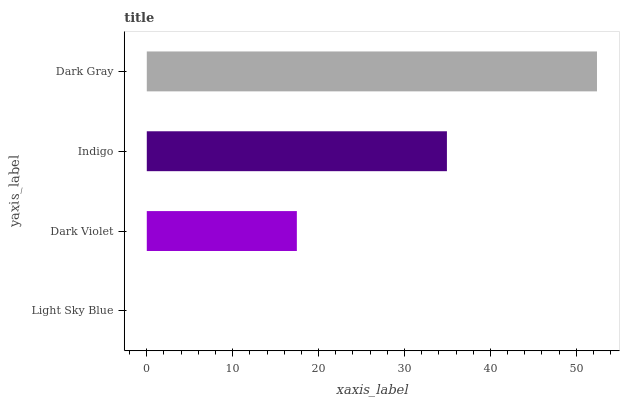Is Light Sky Blue the minimum?
Answer yes or no. Yes. Is Dark Gray the maximum?
Answer yes or no. Yes. Is Dark Violet the minimum?
Answer yes or no. No. Is Dark Violet the maximum?
Answer yes or no. No. Is Dark Violet greater than Light Sky Blue?
Answer yes or no. Yes. Is Light Sky Blue less than Dark Violet?
Answer yes or no. Yes. Is Light Sky Blue greater than Dark Violet?
Answer yes or no. No. Is Dark Violet less than Light Sky Blue?
Answer yes or no. No. Is Indigo the high median?
Answer yes or no. Yes. Is Dark Violet the low median?
Answer yes or no. Yes. Is Dark Violet the high median?
Answer yes or no. No. Is Dark Gray the low median?
Answer yes or no. No. 